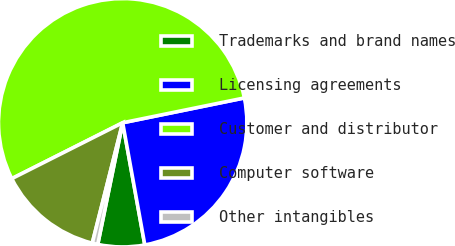<chart> <loc_0><loc_0><loc_500><loc_500><pie_chart><fcel>Trademarks and brand names<fcel>Licensing agreements<fcel>Customer and distributor<fcel>Computer software<fcel>Other intangibles<nl><fcel>6.07%<fcel>25.35%<fcel>54.23%<fcel>13.63%<fcel>0.72%<nl></chart> 